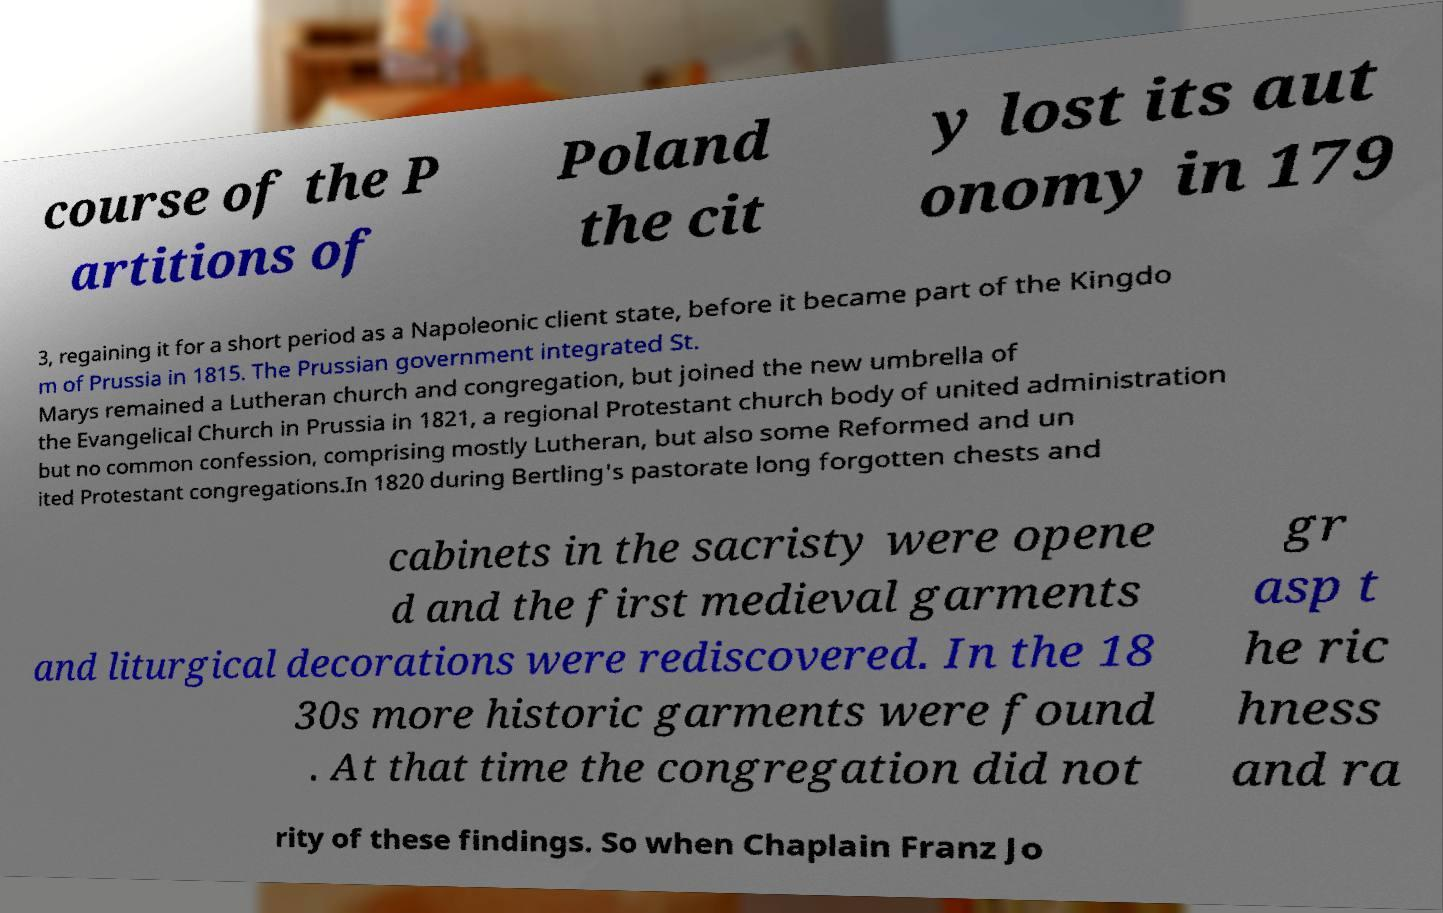I need the written content from this picture converted into text. Can you do that? course of the P artitions of Poland the cit y lost its aut onomy in 179 3, regaining it for a short period as a Napoleonic client state, before it became part of the Kingdo m of Prussia in 1815. The Prussian government integrated St. Marys remained a Lutheran church and congregation, but joined the new umbrella of the Evangelical Church in Prussia in 1821, a regional Protestant church body of united administration but no common confession, comprising mostly Lutheran, but also some Reformed and un ited Protestant congregations.In 1820 during Bertling's pastorate long forgotten chests and cabinets in the sacristy were opene d and the first medieval garments and liturgical decorations were rediscovered. In the 18 30s more historic garments were found . At that time the congregation did not gr asp t he ric hness and ra rity of these findings. So when Chaplain Franz Jo 